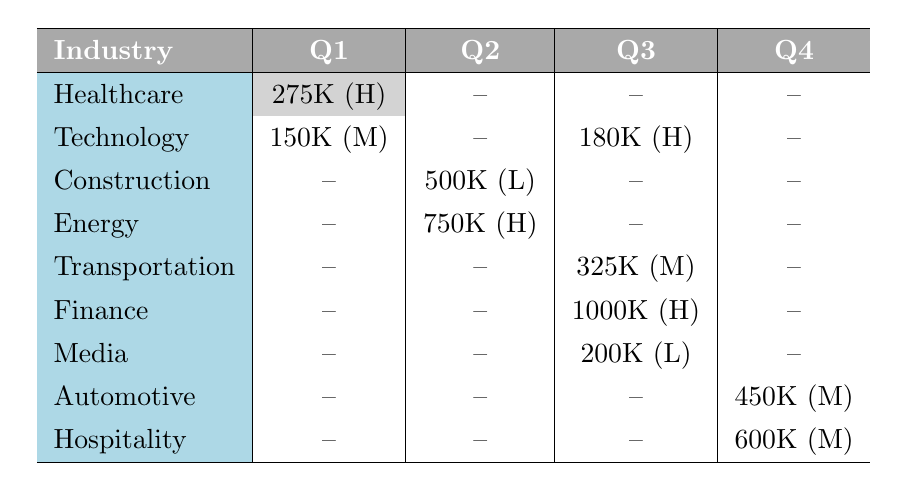What is the highest transaction amount recorded in Q3? In Q3, the recorded transaction amounts are 1000K in Finance, 325K in Transportation, and 200K in Media. The highest among these is 1000K in Finance.
Answer: 1000K Which industry had a transaction flagged as "Unusual volume" and in which quarter did it occur? The industry that had a transaction flagged as "Unusual volume" is Healthcare, with a transaction amount of 275K in Q1.
Answer: Healthcare, Q1 How many industries reported transactions in Q2? In Q2, the industries with reported transactions are Technology (150K), Construction (500K), and Energy (750K). This totals three distinct industries.
Answer: 3 Is there a transaction from the Automotive industry that is flagged as high suspicion? Reviewing the table, the Automotive industry has a transaction amount of 450K listed as medium suspicion. Therefore, there is no transaction flagged as high suspicion.
Answer: No What is the total transaction amount across all industries in Q4? The only transactions in Q4 are in the Automotive industry for 450K and in Hospitality for 600K. So, the total amount is 450K + 600K = 1050K.
Answer: 1050K Which industry recorded the highest suspect level transaction amount in Q2? In Q2, the only suspect level transaction reported is in Technology (150K with medium suspicion). There are no higher suspect level transactions in Q2.
Answer: 150K Were there any low suspect level transactions reported in Q3? Yes, in Q3, a transaction from the Media industry was reported at 200K with a low suspect level.
Answer: Yes What is the average transaction amount for all high suspect level transactions? High suspect transactions occur in Healthcare (275K), Energy (750K), Finance (1000K), and Technology (180K). To find the average, sum these amounts: 275K + 750K + 1000K + 180K = 2205K. There are 4 transactions, so the average is 2205K / 4 = 551.25K.
Answer: 551.25K 